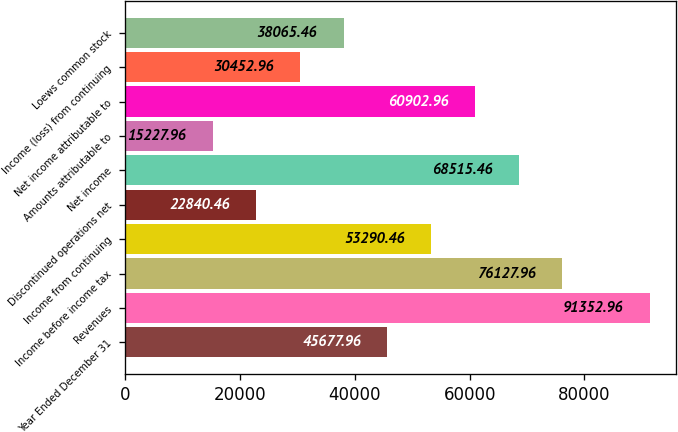Convert chart. <chart><loc_0><loc_0><loc_500><loc_500><bar_chart><fcel>Year Ended December 31<fcel>Revenues<fcel>Income before income tax<fcel>Income from continuing<fcel>Discontinued operations net<fcel>Net income<fcel>Amounts attributable to<fcel>Net income attributable to<fcel>Income (loss) from continuing<fcel>Loews common stock<nl><fcel>45678<fcel>91353<fcel>76128<fcel>53290.5<fcel>22840.5<fcel>68515.5<fcel>15228<fcel>60903<fcel>30453<fcel>38065.5<nl></chart> 